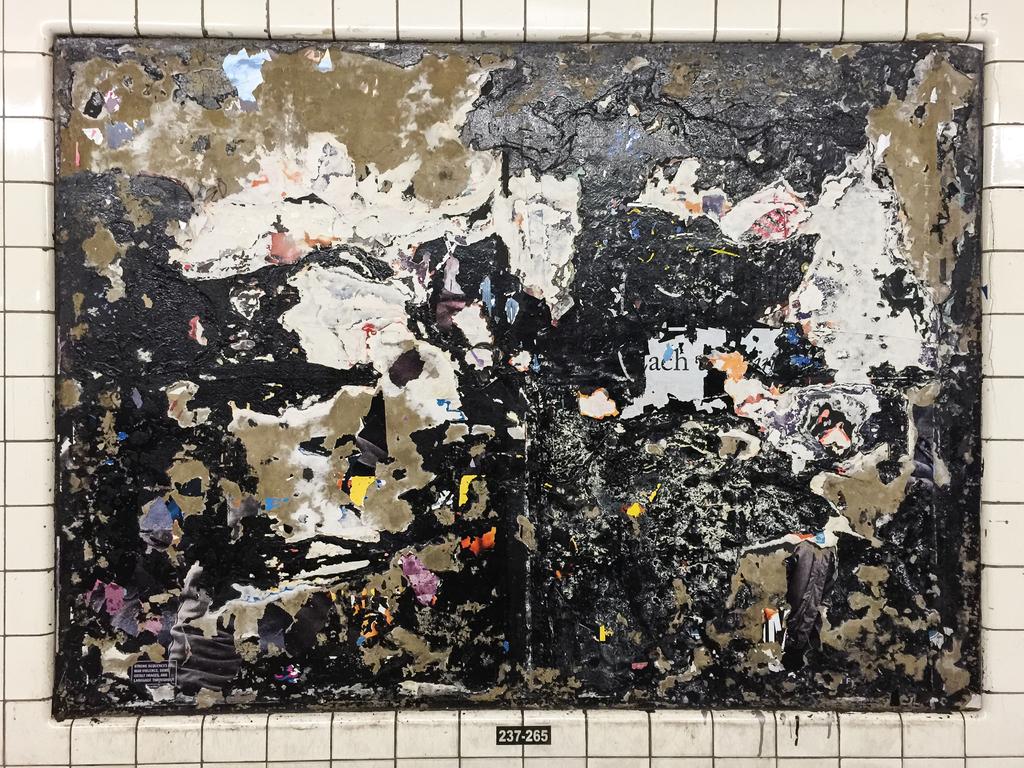What number is underneath the painting?
Keep it short and to the point. 237-265. 